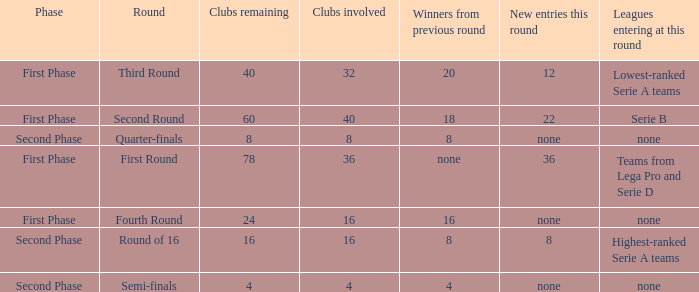The new entries this round was shown to be 12, in which phase would you find this? First Phase. 